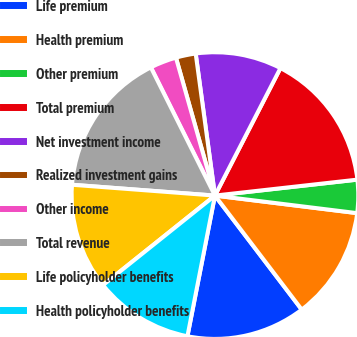Convert chart. <chart><loc_0><loc_0><loc_500><loc_500><pie_chart><fcel>Life premium<fcel>Health premium<fcel>Other premium<fcel>Total premium<fcel>Net investment income<fcel>Realized investment gains<fcel>Other income<fcel>Total revenue<fcel>Life policyholder benefits<fcel>Health policyholder benefits<nl><fcel>13.43%<fcel>12.69%<fcel>3.73%<fcel>15.67%<fcel>9.7%<fcel>2.24%<fcel>2.99%<fcel>16.42%<fcel>11.94%<fcel>11.19%<nl></chart> 